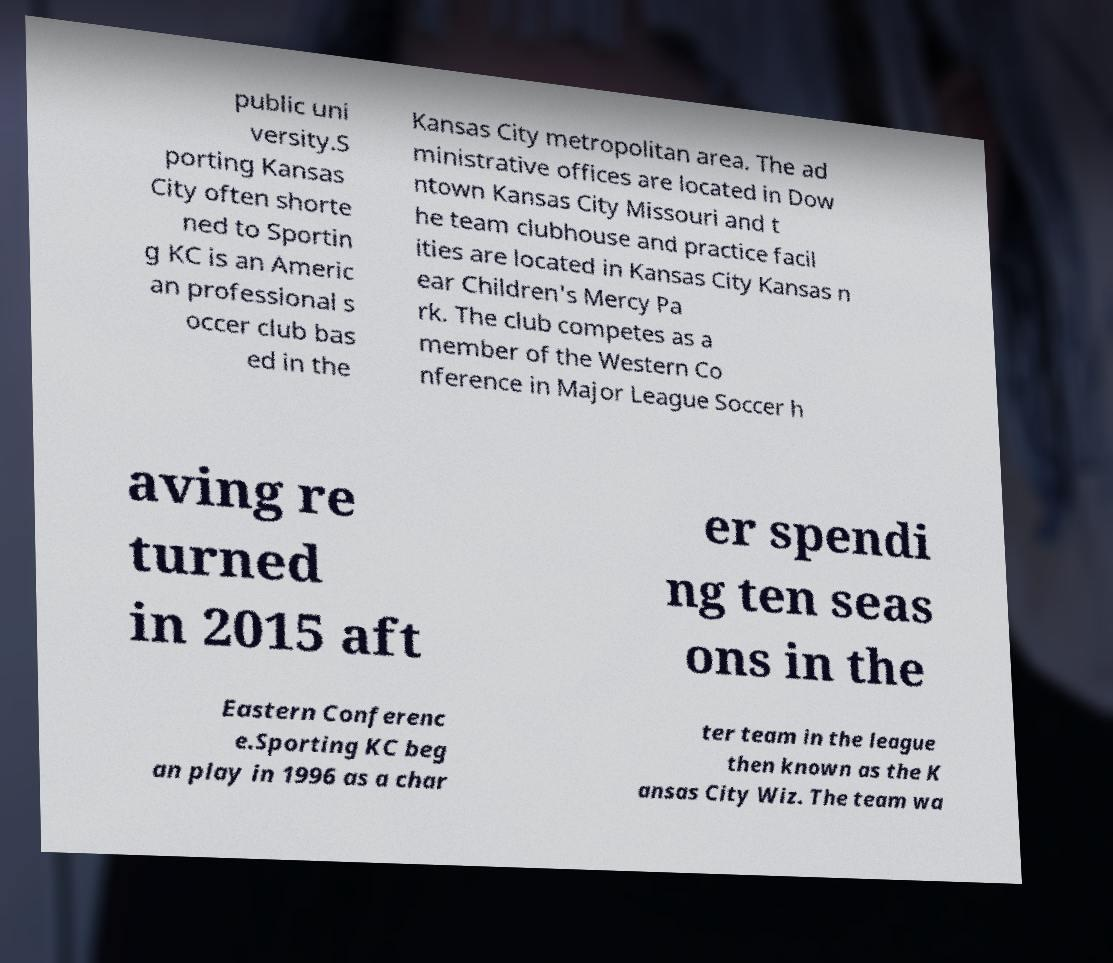There's text embedded in this image that I need extracted. Can you transcribe it verbatim? public uni versity.S porting Kansas City often shorte ned to Sportin g KC is an Americ an professional s occer club bas ed in the Kansas City metropolitan area. The ad ministrative offices are located in Dow ntown Kansas City Missouri and t he team clubhouse and practice facil ities are located in Kansas City Kansas n ear Children's Mercy Pa rk. The club competes as a member of the Western Co nference in Major League Soccer h aving re turned in 2015 aft er spendi ng ten seas ons in the Eastern Conferenc e.Sporting KC beg an play in 1996 as a char ter team in the league then known as the K ansas City Wiz. The team wa 